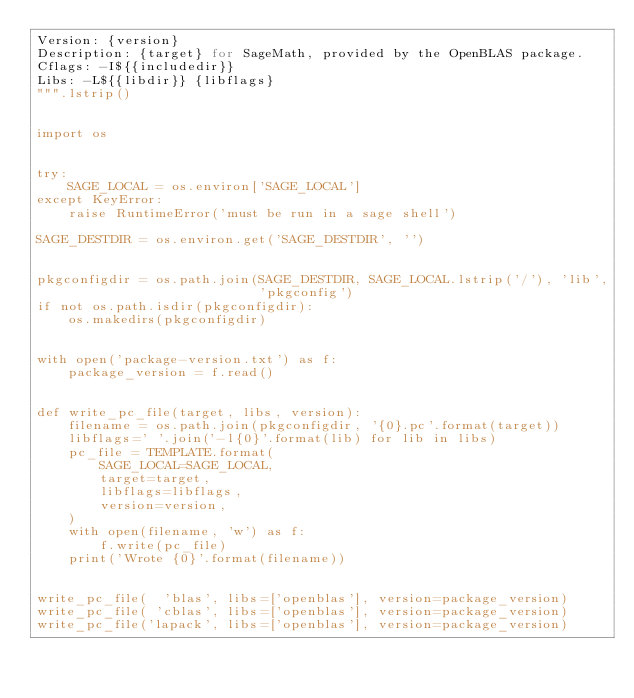<code> <loc_0><loc_0><loc_500><loc_500><_Python_>Version: {version}
Description: {target} for SageMath, provided by the OpenBLAS package.
Cflags: -I${{includedir}}
Libs: -L${{libdir}} {libflags}
""".lstrip()


import os


try:
    SAGE_LOCAL = os.environ['SAGE_LOCAL']
except KeyError:
    raise RuntimeError('must be run in a sage shell')

SAGE_DESTDIR = os.environ.get('SAGE_DESTDIR', '')


pkgconfigdir = os.path.join(SAGE_DESTDIR, SAGE_LOCAL.lstrip('/'), 'lib',
                            'pkgconfig')
if not os.path.isdir(pkgconfigdir):
    os.makedirs(pkgconfigdir)


with open('package-version.txt') as f:
    package_version = f.read()


def write_pc_file(target, libs, version):
    filename = os.path.join(pkgconfigdir, '{0}.pc'.format(target))
    libflags=' '.join('-l{0}'.format(lib) for lib in libs)
    pc_file = TEMPLATE.format(
        SAGE_LOCAL=SAGE_LOCAL,
        target=target,
        libflags=libflags,
        version=version,
    )
    with open(filename, 'w') as f:
        f.write(pc_file)
    print('Wrote {0}'.format(filename))


write_pc_file(  'blas', libs=['openblas'], version=package_version)
write_pc_file( 'cblas', libs=['openblas'], version=package_version)
write_pc_file('lapack', libs=['openblas'], version=package_version)
</code> 